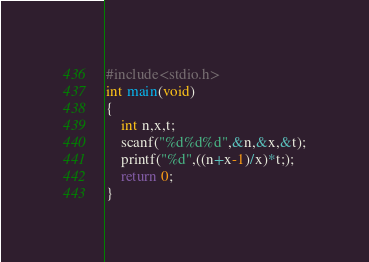<code> <loc_0><loc_0><loc_500><loc_500><_C_>#include<stdio.h>
int main(void)
{
    int n,x,t;
    scanf("%d%d%d",&n,&x,&t);
    printf("%d",((n+x-1)/x)*t;);
    return 0;
}</code> 